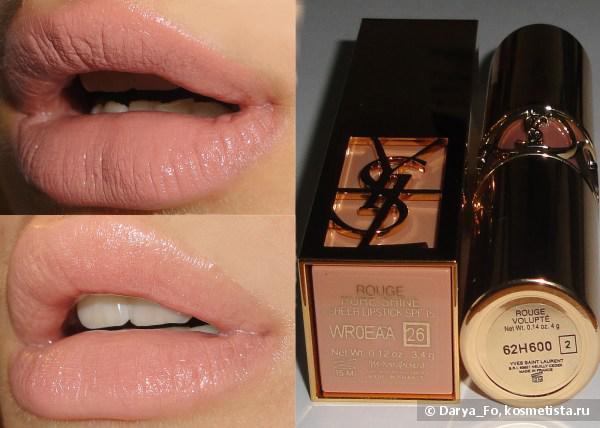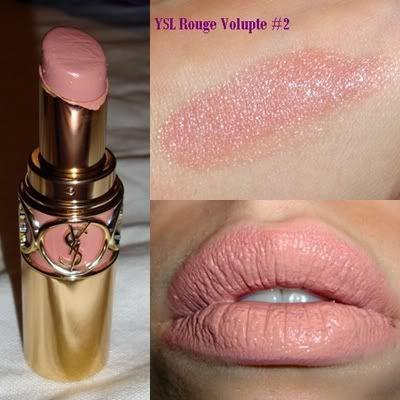The first image is the image on the left, the second image is the image on the right. Analyze the images presented: Is the assertion "YSL Rouge Volupte #2 is featured." valid? Answer yes or no. Yes. The first image is the image on the left, the second image is the image on the right. Evaluate the accuracy of this statement regarding the images: "Both images in the pair show lipstick shades displayed on lips.". Is it true? Answer yes or no. Yes. 